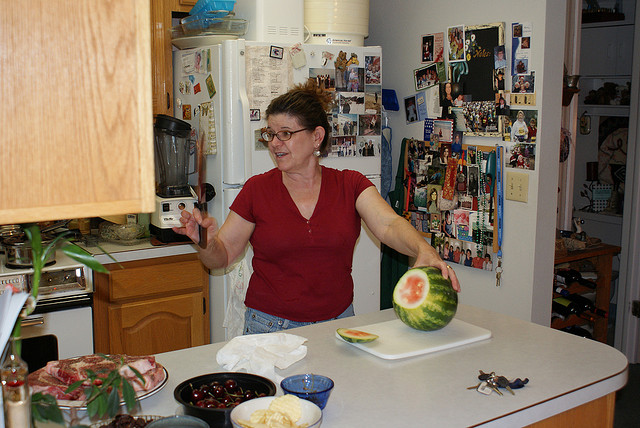What might the person be feeling or experiencing? Judging by her expressive body language and facial expressions, the person seems to be experiencing a moment of joy or fun, perhaps sharing a joke or playful moment with someone off-camera. Her casual attire and the informal setting contribute to the laid-back and comfortable atmosphere. 